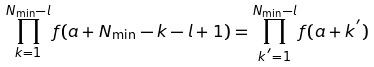Convert formula to latex. <formula><loc_0><loc_0><loc_500><loc_500>\prod _ { k = 1 } ^ { N _ { \min } - l } f ( a + N _ { \min } - k - l + 1 ) = \prod _ { k ^ { ^ { \prime } } = 1 } ^ { N _ { \min } - l } f ( a + k ^ { ^ { \prime } } )</formula> 